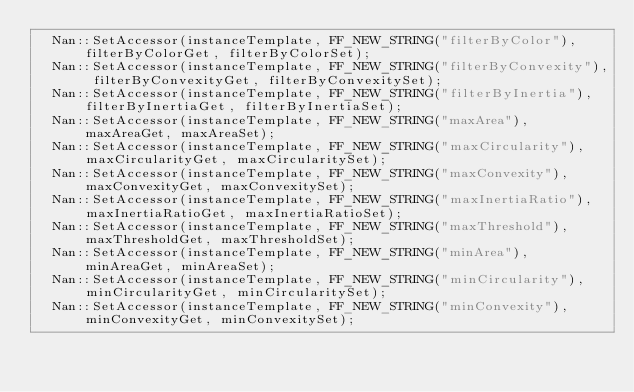<code> <loc_0><loc_0><loc_500><loc_500><_C++_>	Nan::SetAccessor(instanceTemplate, FF_NEW_STRING("filterByColor"), filterByColorGet, filterByColorSet);
  Nan::SetAccessor(instanceTemplate, FF_NEW_STRING("filterByConvexity"), filterByConvexityGet, filterByConvexitySet);
	Nan::SetAccessor(instanceTemplate, FF_NEW_STRING("filterByInertia"), filterByInertiaGet, filterByInertiaSet);
	Nan::SetAccessor(instanceTemplate, FF_NEW_STRING("maxArea"), maxAreaGet, maxAreaSet);
	Nan::SetAccessor(instanceTemplate, FF_NEW_STRING("maxCircularity"), maxCircularityGet, maxCircularitySet);
	Nan::SetAccessor(instanceTemplate, FF_NEW_STRING("maxConvexity"), maxConvexityGet, maxConvexitySet);
	Nan::SetAccessor(instanceTemplate, FF_NEW_STRING("maxInertiaRatio"), maxInertiaRatioGet, maxInertiaRatioSet);
  Nan::SetAccessor(instanceTemplate, FF_NEW_STRING("maxThreshold"), maxThresholdGet, maxThresholdSet);
  Nan::SetAccessor(instanceTemplate, FF_NEW_STRING("minArea"), minAreaGet, minAreaSet);
  Nan::SetAccessor(instanceTemplate, FF_NEW_STRING("minCircularity"), minCircularityGet, minCircularitySet);
  Nan::SetAccessor(instanceTemplate, FF_NEW_STRING("minConvexity"), minConvexityGet, minConvexitySet);</code> 